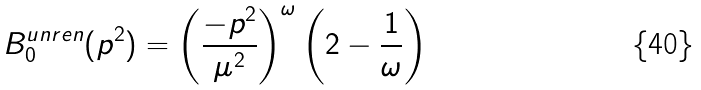Convert formula to latex. <formula><loc_0><loc_0><loc_500><loc_500>B _ { 0 } ^ { u n r e n } ( p ^ { 2 } ) = \left ( \frac { - p ^ { 2 } } { \mu ^ { 2 } } \right ) ^ { \omega } \left ( 2 - \frac { 1 } { \omega } \right )</formula> 